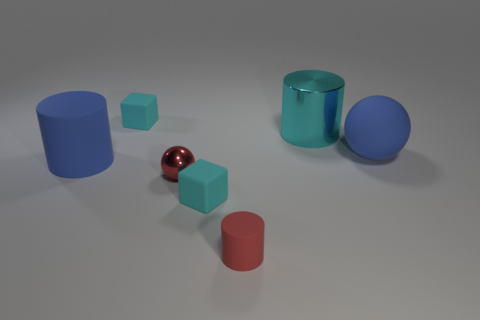What is the material of the big cyan object that is the same shape as the tiny red matte thing? The big cyan object, which shares the cylindrical shape of the tiny red matte item, appears to be made of a glossy, reflective material, indicative of metal or a metal-like substance with a smooth finish. 